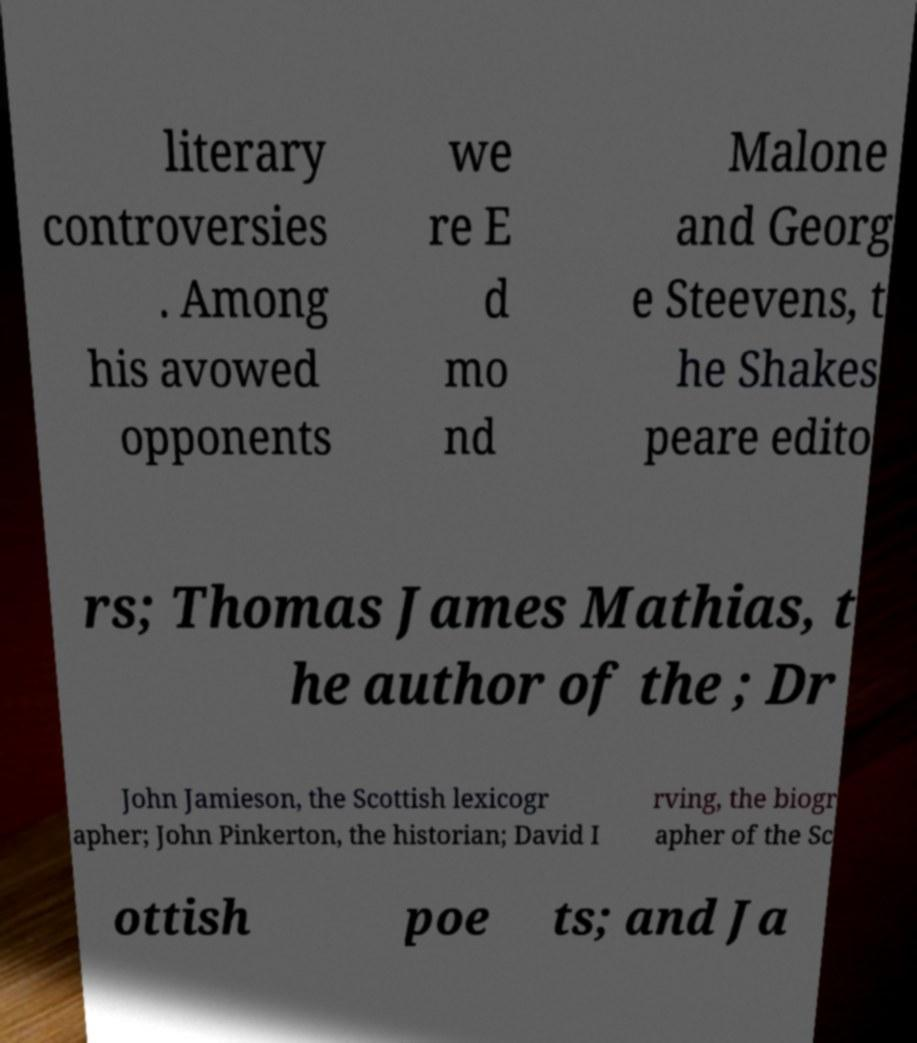What messages or text are displayed in this image? I need them in a readable, typed format. literary controversies . Among his avowed opponents we re E d mo nd Malone and Georg e Steevens, t he Shakes peare edito rs; Thomas James Mathias, t he author of the ; Dr John Jamieson, the Scottish lexicogr apher; John Pinkerton, the historian; David I rving, the biogr apher of the Sc ottish poe ts; and Ja 